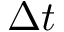Convert formula to latex. <formula><loc_0><loc_0><loc_500><loc_500>\Delta t</formula> 